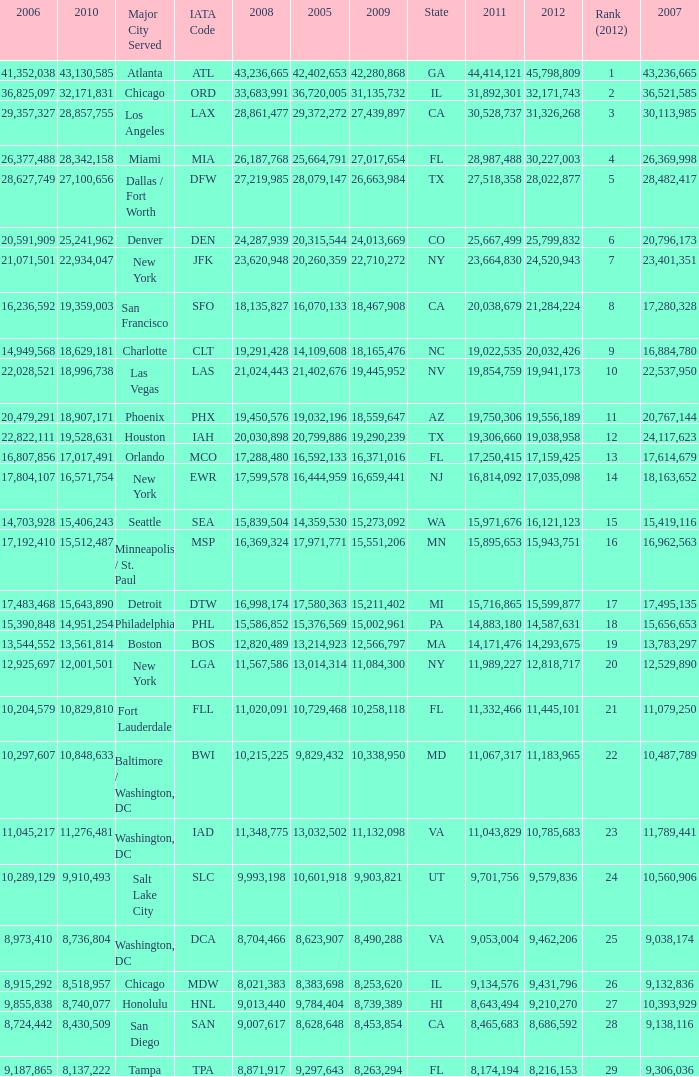When Philadelphia has a 2007 less than 20,796,173 and a 2008 more than 10,215,225, what is the smallest 2009? 15002961.0. 